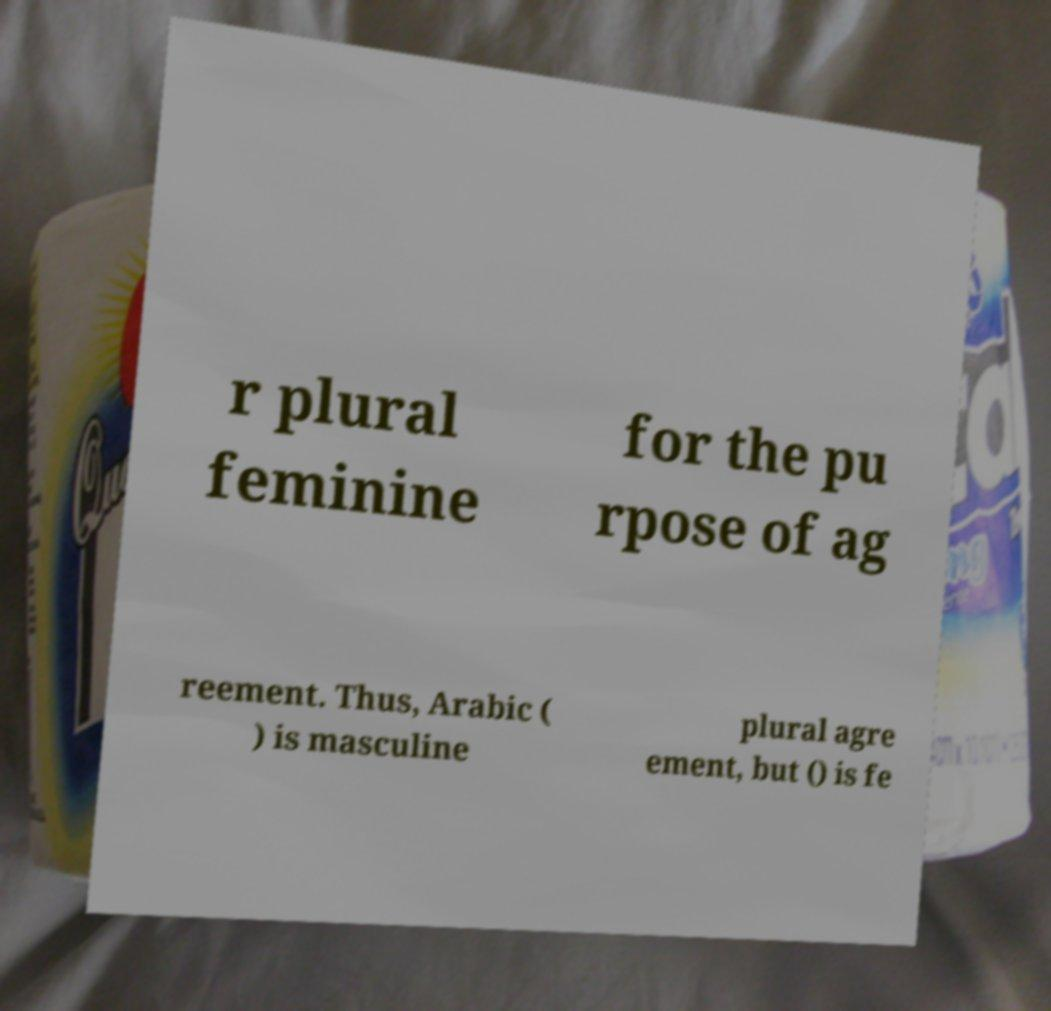There's text embedded in this image that I need extracted. Can you transcribe it verbatim? r plural feminine for the pu rpose of ag reement. Thus, Arabic ( ) is masculine plural agre ement, but () is fe 